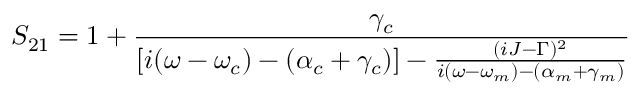Convert formula to latex. <formula><loc_0><loc_0><loc_500><loc_500>S _ { 2 1 } = 1 + \frac { \gamma _ { c } } { [ i ( \omega - \omega _ { c } ) - ( \alpha _ { c } + \gamma _ { c } ) ] - \frac { ( i J - \Gamma ) ^ { 2 } } { i ( \omega - \omega _ { m } ) - ( \alpha _ { m } + \gamma _ { m } ) } }</formula> 